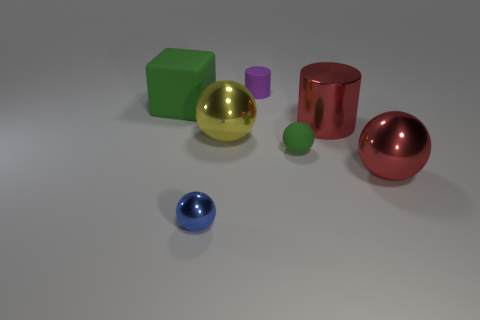Add 3 tiny green balls. How many objects exist? 10 Subtract all blocks. How many objects are left? 6 Subtract 0 cyan cylinders. How many objects are left? 7 Subtract all green balls. Subtract all small purple rubber objects. How many objects are left? 5 Add 6 balls. How many balls are left? 10 Add 5 red shiny cylinders. How many red shiny cylinders exist? 6 